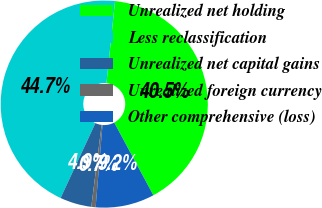Convert chart. <chart><loc_0><loc_0><loc_500><loc_500><pie_chart><fcel>Unrealized net holding<fcel>Less reclassification<fcel>Unrealized net capital gains<fcel>Unrealized foreign currency<fcel>Other comprehensive (loss)<nl><fcel>40.48%<fcel>44.74%<fcel>4.93%<fcel>0.67%<fcel>9.19%<nl></chart> 